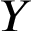Convert formula to latex. <formula><loc_0><loc_0><loc_500><loc_500>Y</formula> 